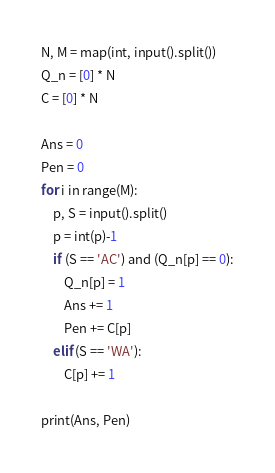<code> <loc_0><loc_0><loc_500><loc_500><_Python_>N, M = map(int, input().split())
Q_n = [0] * N
C = [0] * N

Ans = 0
Pen = 0
for i in range(M):
    p, S = input().split()
    p = int(p)-1
    if (S == 'AC') and (Q_n[p] == 0):
        Q_n[p] = 1
        Ans += 1
        Pen += C[p]
    elif (S == 'WA'):
        C[p] += 1
        
print(Ans, Pen)</code> 